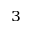<formula> <loc_0><loc_0><loc_500><loc_500>^ { 3 }</formula> 